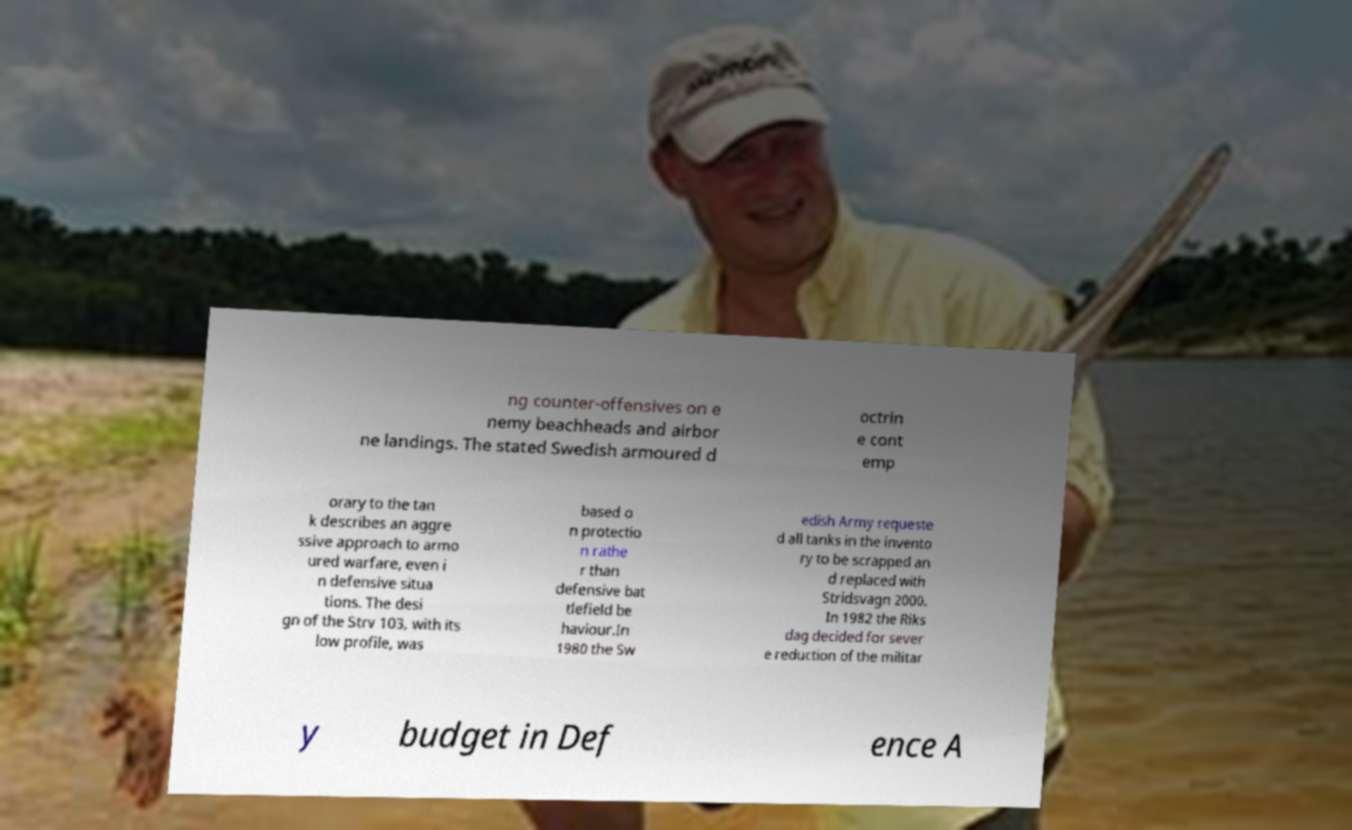Could you extract and type out the text from this image? ng counter-offensives on e nemy beachheads and airbor ne landings. The stated Swedish armoured d octrin e cont emp orary to the tan k describes an aggre ssive approach to armo ured warfare, even i n defensive situa tions. The desi gn of the Strv 103, with its low profile, was based o n protectio n rathe r than defensive bat tlefield be haviour.In 1980 the Sw edish Army requeste d all tanks in the invento ry to be scrapped an d replaced with Stridsvagn 2000. In 1982 the Riks dag decided for sever e reduction of the militar y budget in Def ence A 